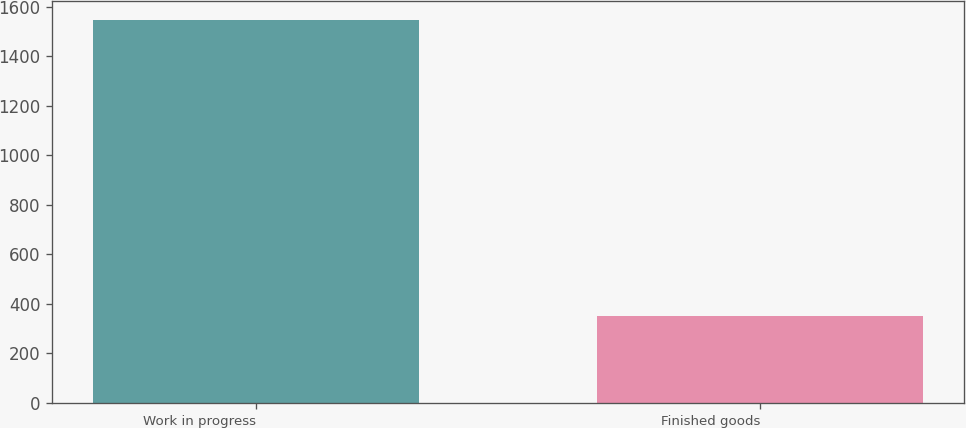<chart> <loc_0><loc_0><loc_500><loc_500><bar_chart><fcel>Work in progress<fcel>Finished goods<nl><fcel>1547<fcel>352<nl></chart> 